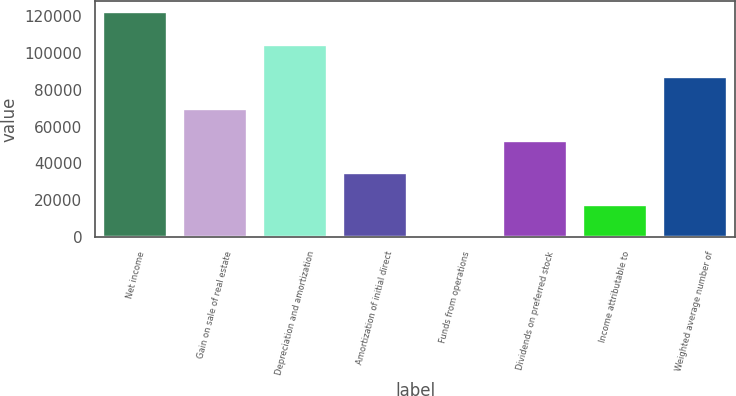<chart> <loc_0><loc_0><loc_500><loc_500><bar_chart><fcel>Net income<fcel>Gain on sale of real estate<fcel>Depreciation and amortization<fcel>Amortization of initial direct<fcel>Funds from operations<fcel>Dividends on preferred stock<fcel>Income attributable to<fcel>Weighted average number of<nl><fcel>121953<fcel>69689<fcel>104532<fcel>34846<fcel>3.06<fcel>52267.5<fcel>17424.5<fcel>87110.5<nl></chart> 